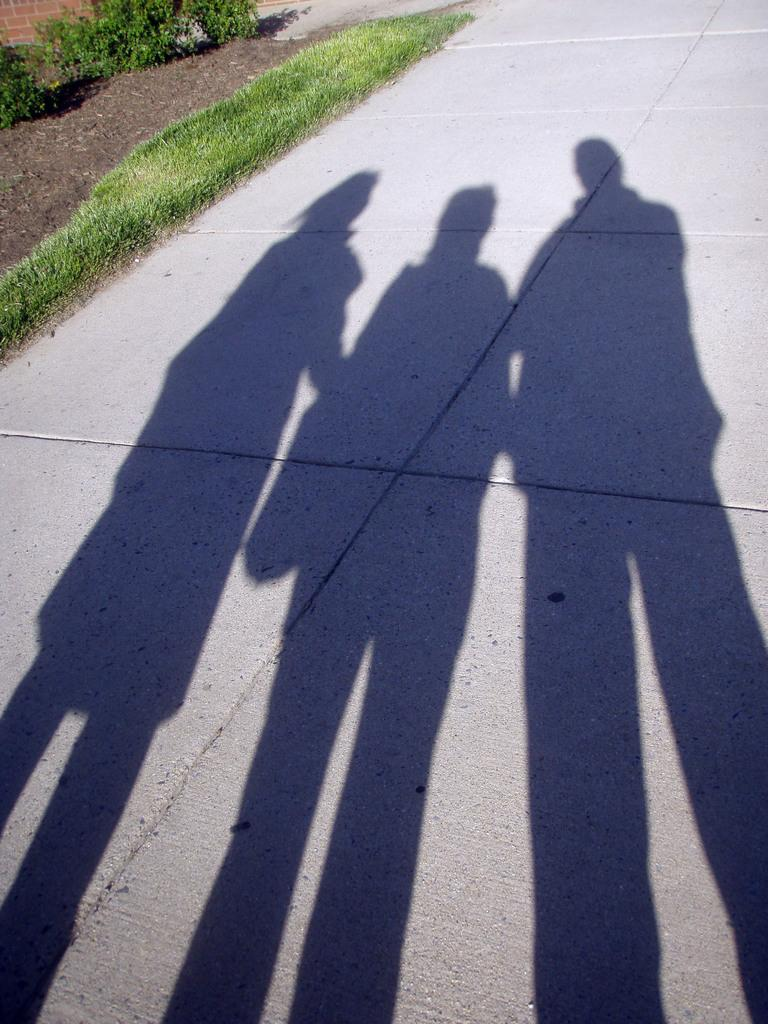How many people's shadows can be seen on the road in the image? There are shadows of three people on the road in the image. What type of vegetation is present on the left side of the image? There is grass and shrubs on the left side of the image. What type of care can be seen being provided to the shrubs in the image? There is no care being provided to the shrubs in the image; they are simply present in the scene. What type of art is being created by the shadows in the image? The shadows in the image are not creating any art; they are simply the result of the people and their interaction with the sunlight. 